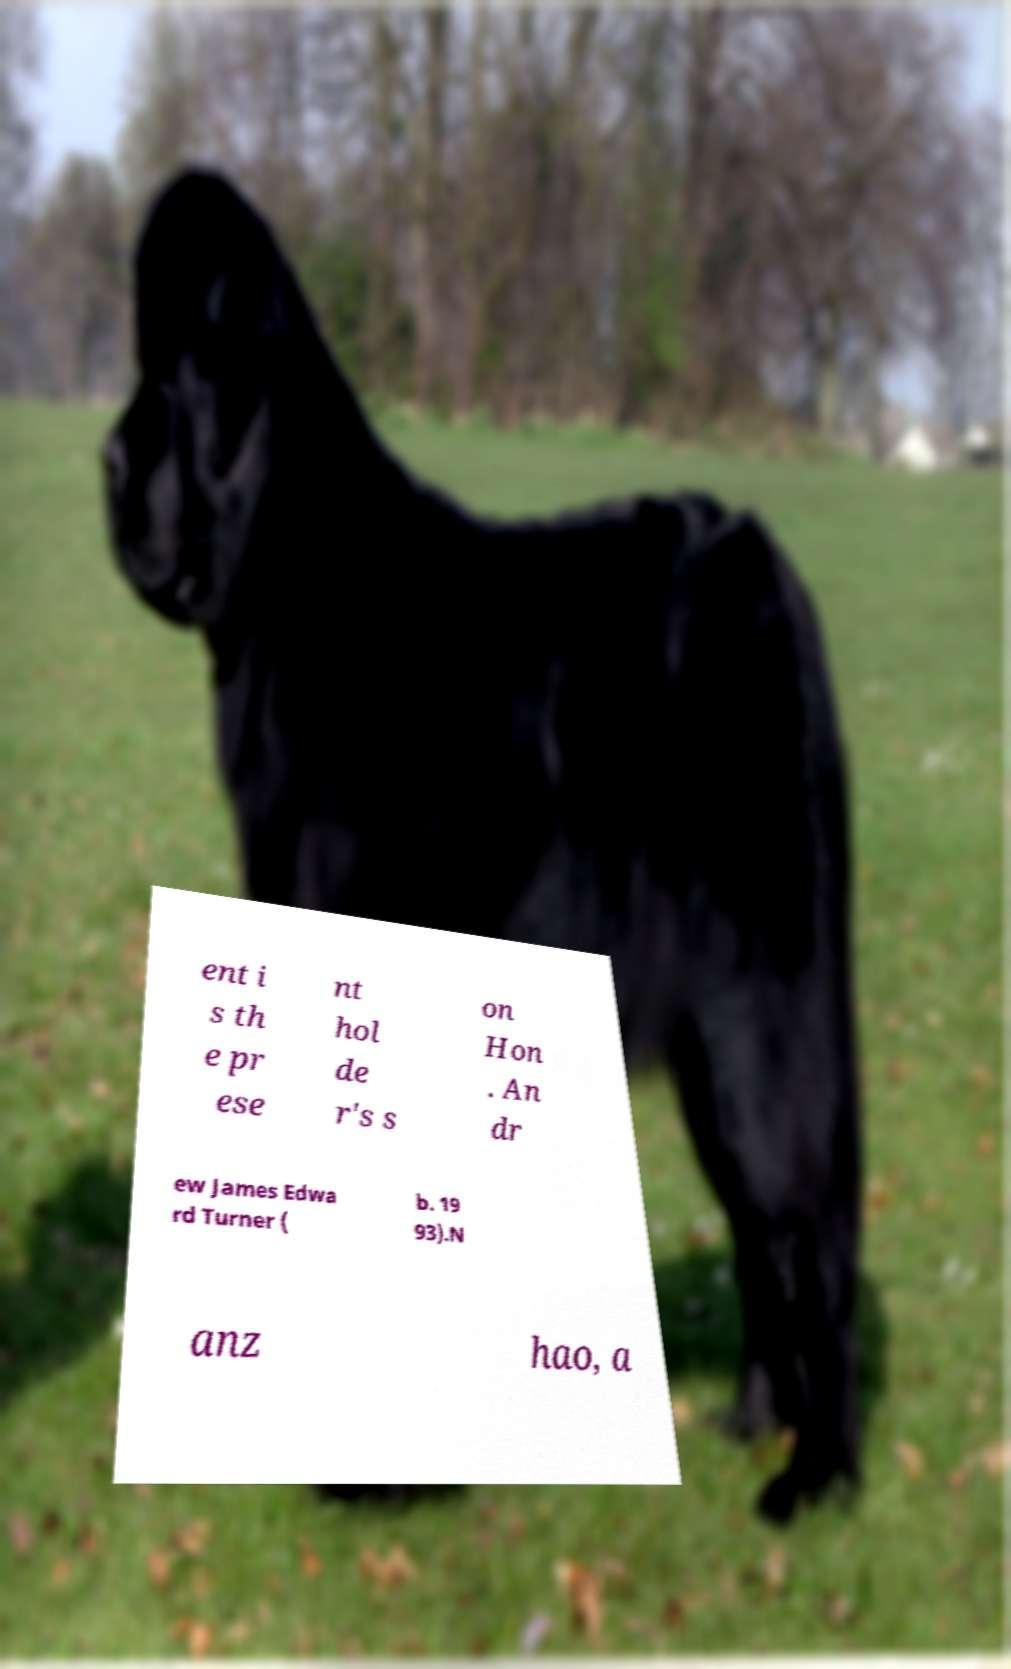Can you read and provide the text displayed in the image?This photo seems to have some interesting text. Can you extract and type it out for me? ent i s th e pr ese nt hol de r's s on Hon . An dr ew James Edwa rd Turner ( b. 19 93).N anz hao, a 